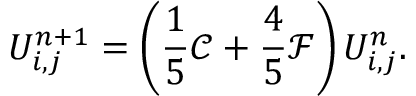Convert formula to latex. <formula><loc_0><loc_0><loc_500><loc_500>U _ { i , j } ^ { n + 1 } = \left ( \frac { 1 } { 5 } \mathcal { C } + \frac { 4 } { 5 } \mathcal { F } \right ) U _ { i , j } ^ { n } .</formula> 